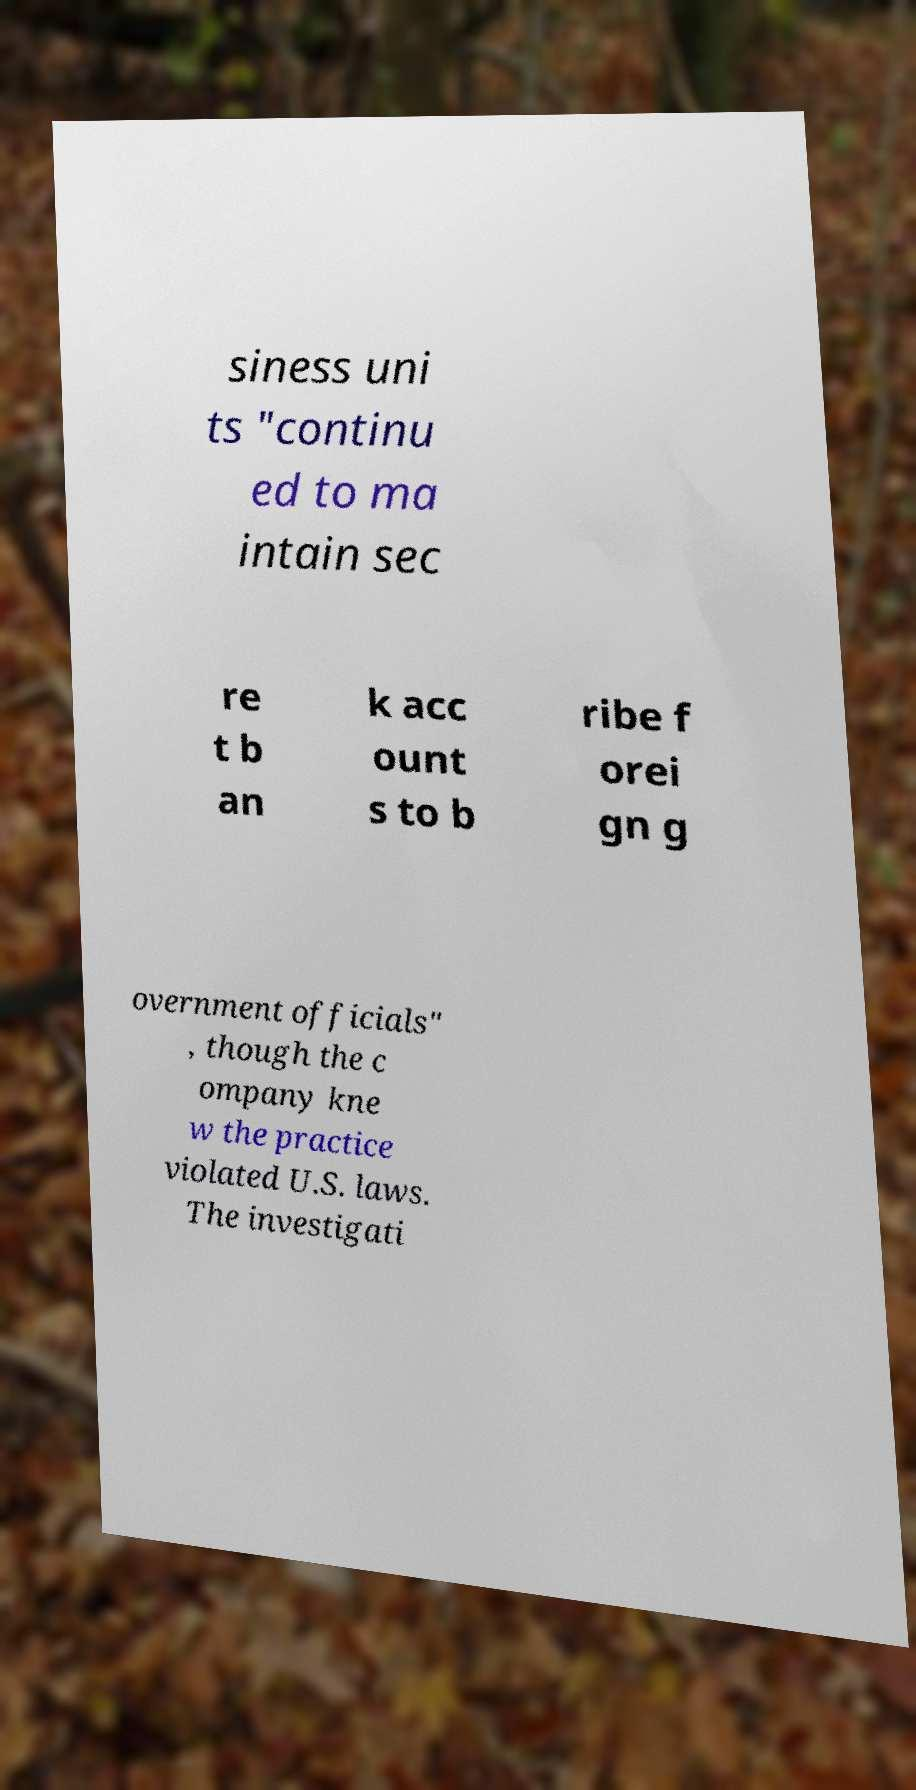What messages or text are displayed in this image? I need them in a readable, typed format. siness uni ts "continu ed to ma intain sec re t b an k acc ount s to b ribe f orei gn g overnment officials" , though the c ompany kne w the practice violated U.S. laws. The investigati 